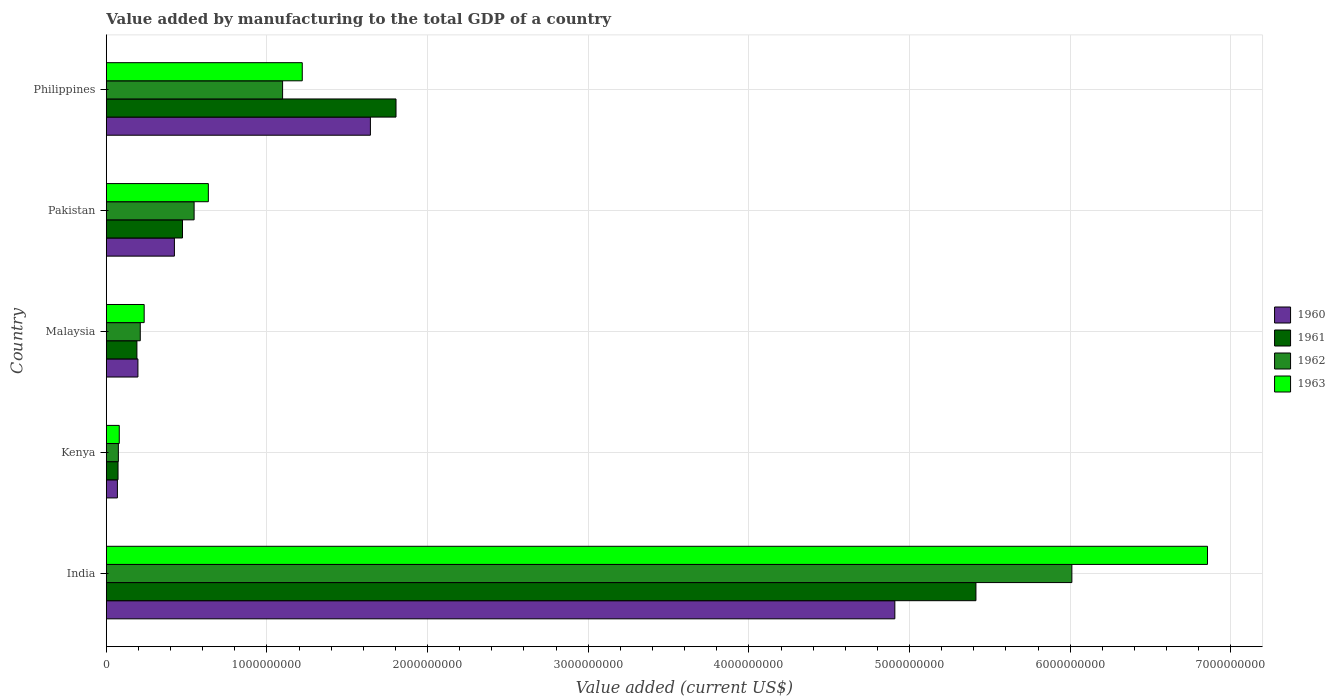How many groups of bars are there?
Offer a very short reply. 5. How many bars are there on the 3rd tick from the bottom?
Make the answer very short. 4. What is the label of the 4th group of bars from the top?
Give a very brief answer. Kenya. What is the value added by manufacturing to the total GDP in 1963 in Pakistan?
Offer a very short reply. 6.35e+08. Across all countries, what is the maximum value added by manufacturing to the total GDP in 1962?
Your response must be concise. 6.01e+09. Across all countries, what is the minimum value added by manufacturing to the total GDP in 1961?
Your response must be concise. 7.28e+07. In which country was the value added by manufacturing to the total GDP in 1960 maximum?
Ensure brevity in your answer.  India. In which country was the value added by manufacturing to the total GDP in 1960 minimum?
Your answer should be compact. Kenya. What is the total value added by manufacturing to the total GDP in 1960 in the graph?
Your response must be concise. 7.24e+09. What is the difference between the value added by manufacturing to the total GDP in 1962 in Kenya and that in Malaysia?
Offer a very short reply. -1.36e+08. What is the difference between the value added by manufacturing to the total GDP in 1960 in India and the value added by manufacturing to the total GDP in 1961 in Malaysia?
Keep it short and to the point. 4.72e+09. What is the average value added by manufacturing to the total GDP in 1961 per country?
Offer a very short reply. 1.59e+09. What is the difference between the value added by manufacturing to the total GDP in 1963 and value added by manufacturing to the total GDP in 1961 in India?
Keep it short and to the point. 1.44e+09. In how many countries, is the value added by manufacturing to the total GDP in 1960 greater than 5400000000 US$?
Provide a succinct answer. 0. What is the ratio of the value added by manufacturing to the total GDP in 1960 in Kenya to that in Pakistan?
Provide a short and direct response. 0.16. Is the value added by manufacturing to the total GDP in 1963 in India less than that in Pakistan?
Ensure brevity in your answer.  No. What is the difference between the highest and the second highest value added by manufacturing to the total GDP in 1960?
Make the answer very short. 3.26e+09. What is the difference between the highest and the lowest value added by manufacturing to the total GDP in 1960?
Your response must be concise. 4.84e+09. In how many countries, is the value added by manufacturing to the total GDP in 1960 greater than the average value added by manufacturing to the total GDP in 1960 taken over all countries?
Give a very brief answer. 2. Is the sum of the value added by manufacturing to the total GDP in 1963 in Kenya and Malaysia greater than the maximum value added by manufacturing to the total GDP in 1960 across all countries?
Your answer should be compact. No. Is it the case that in every country, the sum of the value added by manufacturing to the total GDP in 1963 and value added by manufacturing to the total GDP in 1962 is greater than the sum of value added by manufacturing to the total GDP in 1960 and value added by manufacturing to the total GDP in 1961?
Offer a terse response. No. What does the 4th bar from the top in Malaysia represents?
Provide a short and direct response. 1960. What does the 2nd bar from the bottom in Pakistan represents?
Give a very brief answer. 1961. How many bars are there?
Provide a succinct answer. 20. How many countries are there in the graph?
Provide a succinct answer. 5. What is the difference between two consecutive major ticks on the X-axis?
Offer a very short reply. 1.00e+09. Are the values on the major ticks of X-axis written in scientific E-notation?
Provide a succinct answer. No. Does the graph contain any zero values?
Give a very brief answer. No. How are the legend labels stacked?
Your answer should be very brief. Vertical. What is the title of the graph?
Offer a terse response. Value added by manufacturing to the total GDP of a country. Does "2003" appear as one of the legend labels in the graph?
Your answer should be very brief. No. What is the label or title of the X-axis?
Provide a short and direct response. Value added (current US$). What is the label or title of the Y-axis?
Provide a short and direct response. Country. What is the Value added (current US$) in 1960 in India?
Offer a very short reply. 4.91e+09. What is the Value added (current US$) of 1961 in India?
Your answer should be compact. 5.41e+09. What is the Value added (current US$) of 1962 in India?
Provide a short and direct response. 6.01e+09. What is the Value added (current US$) in 1963 in India?
Your answer should be very brief. 6.85e+09. What is the Value added (current US$) of 1960 in Kenya?
Give a very brief answer. 6.89e+07. What is the Value added (current US$) of 1961 in Kenya?
Make the answer very short. 7.28e+07. What is the Value added (current US$) in 1962 in Kenya?
Your response must be concise. 7.48e+07. What is the Value added (current US$) in 1963 in Kenya?
Your answer should be very brief. 8.05e+07. What is the Value added (current US$) in 1960 in Malaysia?
Provide a succinct answer. 1.97e+08. What is the Value added (current US$) of 1961 in Malaysia?
Keep it short and to the point. 1.90e+08. What is the Value added (current US$) in 1962 in Malaysia?
Give a very brief answer. 2.11e+08. What is the Value added (current US$) of 1963 in Malaysia?
Offer a terse response. 2.36e+08. What is the Value added (current US$) of 1960 in Pakistan?
Make the answer very short. 4.24e+08. What is the Value added (current US$) in 1961 in Pakistan?
Provide a succinct answer. 4.74e+08. What is the Value added (current US$) in 1962 in Pakistan?
Provide a succinct answer. 5.46e+08. What is the Value added (current US$) in 1963 in Pakistan?
Ensure brevity in your answer.  6.35e+08. What is the Value added (current US$) of 1960 in Philippines?
Make the answer very short. 1.64e+09. What is the Value added (current US$) of 1961 in Philippines?
Ensure brevity in your answer.  1.80e+09. What is the Value added (current US$) of 1962 in Philippines?
Ensure brevity in your answer.  1.10e+09. What is the Value added (current US$) of 1963 in Philippines?
Your answer should be very brief. 1.22e+09. Across all countries, what is the maximum Value added (current US$) of 1960?
Your answer should be compact. 4.91e+09. Across all countries, what is the maximum Value added (current US$) of 1961?
Keep it short and to the point. 5.41e+09. Across all countries, what is the maximum Value added (current US$) of 1962?
Give a very brief answer. 6.01e+09. Across all countries, what is the maximum Value added (current US$) of 1963?
Ensure brevity in your answer.  6.85e+09. Across all countries, what is the minimum Value added (current US$) in 1960?
Your response must be concise. 6.89e+07. Across all countries, what is the minimum Value added (current US$) of 1961?
Provide a succinct answer. 7.28e+07. Across all countries, what is the minimum Value added (current US$) in 1962?
Give a very brief answer. 7.48e+07. Across all countries, what is the minimum Value added (current US$) of 1963?
Your answer should be very brief. 8.05e+07. What is the total Value added (current US$) in 1960 in the graph?
Your response must be concise. 7.24e+09. What is the total Value added (current US$) of 1961 in the graph?
Offer a terse response. 7.95e+09. What is the total Value added (current US$) of 1962 in the graph?
Provide a succinct answer. 7.94e+09. What is the total Value added (current US$) in 1963 in the graph?
Keep it short and to the point. 9.03e+09. What is the difference between the Value added (current US$) of 1960 in India and that in Kenya?
Your response must be concise. 4.84e+09. What is the difference between the Value added (current US$) of 1961 in India and that in Kenya?
Keep it short and to the point. 5.34e+09. What is the difference between the Value added (current US$) in 1962 in India and that in Kenya?
Provide a succinct answer. 5.94e+09. What is the difference between the Value added (current US$) in 1963 in India and that in Kenya?
Your answer should be compact. 6.77e+09. What is the difference between the Value added (current US$) in 1960 in India and that in Malaysia?
Provide a succinct answer. 4.71e+09. What is the difference between the Value added (current US$) in 1961 in India and that in Malaysia?
Provide a succinct answer. 5.22e+09. What is the difference between the Value added (current US$) in 1962 in India and that in Malaysia?
Provide a short and direct response. 5.80e+09. What is the difference between the Value added (current US$) in 1963 in India and that in Malaysia?
Provide a short and direct response. 6.62e+09. What is the difference between the Value added (current US$) of 1960 in India and that in Pakistan?
Your answer should be very brief. 4.48e+09. What is the difference between the Value added (current US$) in 1961 in India and that in Pakistan?
Offer a very short reply. 4.94e+09. What is the difference between the Value added (current US$) in 1962 in India and that in Pakistan?
Ensure brevity in your answer.  5.46e+09. What is the difference between the Value added (current US$) of 1963 in India and that in Pakistan?
Keep it short and to the point. 6.22e+09. What is the difference between the Value added (current US$) in 1960 in India and that in Philippines?
Give a very brief answer. 3.26e+09. What is the difference between the Value added (current US$) of 1961 in India and that in Philippines?
Provide a short and direct response. 3.61e+09. What is the difference between the Value added (current US$) of 1962 in India and that in Philippines?
Keep it short and to the point. 4.91e+09. What is the difference between the Value added (current US$) in 1963 in India and that in Philippines?
Give a very brief answer. 5.64e+09. What is the difference between the Value added (current US$) in 1960 in Kenya and that in Malaysia?
Your response must be concise. -1.28e+08. What is the difference between the Value added (current US$) of 1961 in Kenya and that in Malaysia?
Ensure brevity in your answer.  -1.18e+08. What is the difference between the Value added (current US$) in 1962 in Kenya and that in Malaysia?
Ensure brevity in your answer.  -1.36e+08. What is the difference between the Value added (current US$) of 1963 in Kenya and that in Malaysia?
Provide a succinct answer. -1.55e+08. What is the difference between the Value added (current US$) in 1960 in Kenya and that in Pakistan?
Your answer should be compact. -3.55e+08. What is the difference between the Value added (current US$) of 1961 in Kenya and that in Pakistan?
Your answer should be very brief. -4.01e+08. What is the difference between the Value added (current US$) in 1962 in Kenya and that in Pakistan?
Provide a succinct answer. -4.72e+08. What is the difference between the Value added (current US$) of 1963 in Kenya and that in Pakistan?
Your answer should be compact. -5.54e+08. What is the difference between the Value added (current US$) of 1960 in Kenya and that in Philippines?
Make the answer very short. -1.57e+09. What is the difference between the Value added (current US$) in 1961 in Kenya and that in Philippines?
Your answer should be compact. -1.73e+09. What is the difference between the Value added (current US$) in 1962 in Kenya and that in Philippines?
Your response must be concise. -1.02e+09. What is the difference between the Value added (current US$) of 1963 in Kenya and that in Philippines?
Provide a succinct answer. -1.14e+09. What is the difference between the Value added (current US$) in 1960 in Malaysia and that in Pakistan?
Your answer should be compact. -2.27e+08. What is the difference between the Value added (current US$) of 1961 in Malaysia and that in Pakistan?
Keep it short and to the point. -2.84e+08. What is the difference between the Value added (current US$) in 1962 in Malaysia and that in Pakistan?
Offer a terse response. -3.35e+08. What is the difference between the Value added (current US$) in 1963 in Malaysia and that in Pakistan?
Your answer should be compact. -3.99e+08. What is the difference between the Value added (current US$) in 1960 in Malaysia and that in Philippines?
Your answer should be very brief. -1.45e+09. What is the difference between the Value added (current US$) of 1961 in Malaysia and that in Philippines?
Offer a terse response. -1.61e+09. What is the difference between the Value added (current US$) of 1962 in Malaysia and that in Philippines?
Give a very brief answer. -8.86e+08. What is the difference between the Value added (current US$) in 1963 in Malaysia and that in Philippines?
Offer a terse response. -9.84e+08. What is the difference between the Value added (current US$) of 1960 in Pakistan and that in Philippines?
Offer a very short reply. -1.22e+09. What is the difference between the Value added (current US$) of 1961 in Pakistan and that in Philippines?
Offer a terse response. -1.33e+09. What is the difference between the Value added (current US$) of 1962 in Pakistan and that in Philippines?
Provide a succinct answer. -5.51e+08. What is the difference between the Value added (current US$) of 1963 in Pakistan and that in Philippines?
Make the answer very short. -5.85e+08. What is the difference between the Value added (current US$) in 1960 in India and the Value added (current US$) in 1961 in Kenya?
Your answer should be very brief. 4.84e+09. What is the difference between the Value added (current US$) in 1960 in India and the Value added (current US$) in 1962 in Kenya?
Provide a short and direct response. 4.83e+09. What is the difference between the Value added (current US$) in 1960 in India and the Value added (current US$) in 1963 in Kenya?
Offer a terse response. 4.83e+09. What is the difference between the Value added (current US$) of 1961 in India and the Value added (current US$) of 1962 in Kenya?
Your response must be concise. 5.34e+09. What is the difference between the Value added (current US$) of 1961 in India and the Value added (current US$) of 1963 in Kenya?
Provide a short and direct response. 5.33e+09. What is the difference between the Value added (current US$) in 1962 in India and the Value added (current US$) in 1963 in Kenya?
Your answer should be compact. 5.93e+09. What is the difference between the Value added (current US$) in 1960 in India and the Value added (current US$) in 1961 in Malaysia?
Ensure brevity in your answer.  4.72e+09. What is the difference between the Value added (current US$) in 1960 in India and the Value added (current US$) in 1962 in Malaysia?
Make the answer very short. 4.70e+09. What is the difference between the Value added (current US$) in 1960 in India and the Value added (current US$) in 1963 in Malaysia?
Provide a succinct answer. 4.67e+09. What is the difference between the Value added (current US$) in 1961 in India and the Value added (current US$) in 1962 in Malaysia?
Provide a short and direct response. 5.20e+09. What is the difference between the Value added (current US$) of 1961 in India and the Value added (current US$) of 1963 in Malaysia?
Offer a terse response. 5.18e+09. What is the difference between the Value added (current US$) in 1962 in India and the Value added (current US$) in 1963 in Malaysia?
Offer a terse response. 5.78e+09. What is the difference between the Value added (current US$) of 1960 in India and the Value added (current US$) of 1961 in Pakistan?
Make the answer very short. 4.43e+09. What is the difference between the Value added (current US$) in 1960 in India and the Value added (current US$) in 1962 in Pakistan?
Your answer should be compact. 4.36e+09. What is the difference between the Value added (current US$) in 1960 in India and the Value added (current US$) in 1963 in Pakistan?
Provide a short and direct response. 4.27e+09. What is the difference between the Value added (current US$) in 1961 in India and the Value added (current US$) in 1962 in Pakistan?
Offer a very short reply. 4.87e+09. What is the difference between the Value added (current US$) of 1961 in India and the Value added (current US$) of 1963 in Pakistan?
Your answer should be very brief. 4.78e+09. What is the difference between the Value added (current US$) of 1962 in India and the Value added (current US$) of 1963 in Pakistan?
Your answer should be compact. 5.38e+09. What is the difference between the Value added (current US$) of 1960 in India and the Value added (current US$) of 1961 in Philippines?
Provide a short and direct response. 3.11e+09. What is the difference between the Value added (current US$) of 1960 in India and the Value added (current US$) of 1962 in Philippines?
Give a very brief answer. 3.81e+09. What is the difference between the Value added (current US$) of 1960 in India and the Value added (current US$) of 1963 in Philippines?
Provide a succinct answer. 3.69e+09. What is the difference between the Value added (current US$) in 1961 in India and the Value added (current US$) in 1962 in Philippines?
Offer a terse response. 4.32e+09. What is the difference between the Value added (current US$) in 1961 in India and the Value added (current US$) in 1963 in Philippines?
Provide a succinct answer. 4.19e+09. What is the difference between the Value added (current US$) in 1962 in India and the Value added (current US$) in 1963 in Philippines?
Provide a short and direct response. 4.79e+09. What is the difference between the Value added (current US$) in 1960 in Kenya and the Value added (current US$) in 1961 in Malaysia?
Your response must be concise. -1.21e+08. What is the difference between the Value added (current US$) of 1960 in Kenya and the Value added (current US$) of 1962 in Malaysia?
Make the answer very short. -1.42e+08. What is the difference between the Value added (current US$) in 1960 in Kenya and the Value added (current US$) in 1963 in Malaysia?
Ensure brevity in your answer.  -1.67e+08. What is the difference between the Value added (current US$) of 1961 in Kenya and the Value added (current US$) of 1962 in Malaysia?
Make the answer very short. -1.38e+08. What is the difference between the Value added (current US$) of 1961 in Kenya and the Value added (current US$) of 1963 in Malaysia?
Provide a succinct answer. -1.63e+08. What is the difference between the Value added (current US$) in 1962 in Kenya and the Value added (current US$) in 1963 in Malaysia?
Your answer should be compact. -1.61e+08. What is the difference between the Value added (current US$) of 1960 in Kenya and the Value added (current US$) of 1961 in Pakistan?
Provide a succinct answer. -4.05e+08. What is the difference between the Value added (current US$) of 1960 in Kenya and the Value added (current US$) of 1962 in Pakistan?
Your answer should be very brief. -4.78e+08. What is the difference between the Value added (current US$) of 1960 in Kenya and the Value added (current US$) of 1963 in Pakistan?
Provide a short and direct response. -5.66e+08. What is the difference between the Value added (current US$) in 1961 in Kenya and the Value added (current US$) in 1962 in Pakistan?
Provide a short and direct response. -4.74e+08. What is the difference between the Value added (current US$) of 1961 in Kenya and the Value added (current US$) of 1963 in Pakistan?
Ensure brevity in your answer.  -5.62e+08. What is the difference between the Value added (current US$) of 1962 in Kenya and the Value added (current US$) of 1963 in Pakistan?
Provide a succinct answer. -5.60e+08. What is the difference between the Value added (current US$) of 1960 in Kenya and the Value added (current US$) of 1961 in Philippines?
Provide a succinct answer. -1.73e+09. What is the difference between the Value added (current US$) of 1960 in Kenya and the Value added (current US$) of 1962 in Philippines?
Make the answer very short. -1.03e+09. What is the difference between the Value added (current US$) of 1960 in Kenya and the Value added (current US$) of 1963 in Philippines?
Offer a very short reply. -1.15e+09. What is the difference between the Value added (current US$) of 1961 in Kenya and the Value added (current US$) of 1962 in Philippines?
Your answer should be very brief. -1.02e+09. What is the difference between the Value added (current US$) in 1961 in Kenya and the Value added (current US$) in 1963 in Philippines?
Provide a succinct answer. -1.15e+09. What is the difference between the Value added (current US$) in 1962 in Kenya and the Value added (current US$) in 1963 in Philippines?
Your response must be concise. -1.14e+09. What is the difference between the Value added (current US$) in 1960 in Malaysia and the Value added (current US$) in 1961 in Pakistan?
Offer a very short reply. -2.78e+08. What is the difference between the Value added (current US$) in 1960 in Malaysia and the Value added (current US$) in 1962 in Pakistan?
Make the answer very short. -3.50e+08. What is the difference between the Value added (current US$) in 1960 in Malaysia and the Value added (current US$) in 1963 in Pakistan?
Offer a very short reply. -4.38e+08. What is the difference between the Value added (current US$) of 1961 in Malaysia and the Value added (current US$) of 1962 in Pakistan?
Provide a short and direct response. -3.56e+08. What is the difference between the Value added (current US$) of 1961 in Malaysia and the Value added (current US$) of 1963 in Pakistan?
Provide a succinct answer. -4.45e+08. What is the difference between the Value added (current US$) of 1962 in Malaysia and the Value added (current US$) of 1963 in Pakistan?
Keep it short and to the point. -4.24e+08. What is the difference between the Value added (current US$) of 1960 in Malaysia and the Value added (current US$) of 1961 in Philippines?
Give a very brief answer. -1.61e+09. What is the difference between the Value added (current US$) of 1960 in Malaysia and the Value added (current US$) of 1962 in Philippines?
Keep it short and to the point. -9.01e+08. What is the difference between the Value added (current US$) of 1960 in Malaysia and the Value added (current US$) of 1963 in Philippines?
Give a very brief answer. -1.02e+09. What is the difference between the Value added (current US$) in 1961 in Malaysia and the Value added (current US$) in 1962 in Philippines?
Offer a terse response. -9.07e+08. What is the difference between the Value added (current US$) of 1961 in Malaysia and the Value added (current US$) of 1963 in Philippines?
Offer a very short reply. -1.03e+09. What is the difference between the Value added (current US$) in 1962 in Malaysia and the Value added (current US$) in 1963 in Philippines?
Keep it short and to the point. -1.01e+09. What is the difference between the Value added (current US$) of 1960 in Pakistan and the Value added (current US$) of 1961 in Philippines?
Offer a very short reply. -1.38e+09. What is the difference between the Value added (current US$) of 1960 in Pakistan and the Value added (current US$) of 1962 in Philippines?
Your response must be concise. -6.74e+08. What is the difference between the Value added (current US$) of 1960 in Pakistan and the Value added (current US$) of 1963 in Philippines?
Offer a very short reply. -7.96e+08. What is the difference between the Value added (current US$) of 1961 in Pakistan and the Value added (current US$) of 1962 in Philippines?
Give a very brief answer. -6.23e+08. What is the difference between the Value added (current US$) of 1961 in Pakistan and the Value added (current US$) of 1963 in Philippines?
Offer a terse response. -7.46e+08. What is the difference between the Value added (current US$) of 1962 in Pakistan and the Value added (current US$) of 1963 in Philippines?
Provide a succinct answer. -6.73e+08. What is the average Value added (current US$) of 1960 per country?
Your answer should be compact. 1.45e+09. What is the average Value added (current US$) in 1961 per country?
Offer a terse response. 1.59e+09. What is the average Value added (current US$) of 1962 per country?
Ensure brevity in your answer.  1.59e+09. What is the average Value added (current US$) in 1963 per country?
Make the answer very short. 1.81e+09. What is the difference between the Value added (current US$) in 1960 and Value added (current US$) in 1961 in India?
Offer a terse response. -5.05e+08. What is the difference between the Value added (current US$) of 1960 and Value added (current US$) of 1962 in India?
Your response must be concise. -1.10e+09. What is the difference between the Value added (current US$) of 1960 and Value added (current US$) of 1963 in India?
Your answer should be very brief. -1.95e+09. What is the difference between the Value added (current US$) of 1961 and Value added (current US$) of 1962 in India?
Give a very brief answer. -5.97e+08. What is the difference between the Value added (current US$) of 1961 and Value added (current US$) of 1963 in India?
Your answer should be compact. -1.44e+09. What is the difference between the Value added (current US$) of 1962 and Value added (current US$) of 1963 in India?
Give a very brief answer. -8.44e+08. What is the difference between the Value added (current US$) in 1960 and Value added (current US$) in 1961 in Kenya?
Give a very brief answer. -3.93e+06. What is the difference between the Value added (current US$) in 1960 and Value added (current US$) in 1962 in Kenya?
Provide a short and direct response. -5.94e+06. What is the difference between the Value added (current US$) of 1960 and Value added (current US$) of 1963 in Kenya?
Offer a terse response. -1.16e+07. What is the difference between the Value added (current US$) in 1961 and Value added (current US$) in 1962 in Kenya?
Provide a succinct answer. -2.00e+06. What is the difference between the Value added (current US$) in 1961 and Value added (current US$) in 1963 in Kenya?
Offer a terse response. -7.70e+06. What is the difference between the Value added (current US$) of 1962 and Value added (current US$) of 1963 in Kenya?
Your answer should be very brief. -5.70e+06. What is the difference between the Value added (current US$) in 1960 and Value added (current US$) in 1961 in Malaysia?
Your answer should be compact. 6.25e+06. What is the difference between the Value added (current US$) in 1960 and Value added (current US$) in 1962 in Malaysia?
Offer a terse response. -1.46e+07. What is the difference between the Value added (current US$) of 1960 and Value added (current US$) of 1963 in Malaysia?
Offer a very short reply. -3.89e+07. What is the difference between the Value added (current US$) in 1961 and Value added (current US$) in 1962 in Malaysia?
Offer a terse response. -2.08e+07. What is the difference between the Value added (current US$) in 1961 and Value added (current US$) in 1963 in Malaysia?
Ensure brevity in your answer.  -4.52e+07. What is the difference between the Value added (current US$) of 1962 and Value added (current US$) of 1963 in Malaysia?
Ensure brevity in your answer.  -2.43e+07. What is the difference between the Value added (current US$) in 1960 and Value added (current US$) in 1961 in Pakistan?
Your answer should be very brief. -5.04e+07. What is the difference between the Value added (current US$) in 1960 and Value added (current US$) in 1962 in Pakistan?
Your response must be concise. -1.23e+08. What is the difference between the Value added (current US$) of 1960 and Value added (current US$) of 1963 in Pakistan?
Your response must be concise. -2.11e+08. What is the difference between the Value added (current US$) in 1961 and Value added (current US$) in 1962 in Pakistan?
Your response must be concise. -7.22e+07. What is the difference between the Value added (current US$) in 1961 and Value added (current US$) in 1963 in Pakistan?
Provide a short and direct response. -1.61e+08. What is the difference between the Value added (current US$) of 1962 and Value added (current US$) of 1963 in Pakistan?
Provide a short and direct response. -8.86e+07. What is the difference between the Value added (current US$) in 1960 and Value added (current US$) in 1961 in Philippines?
Your response must be concise. -1.59e+08. What is the difference between the Value added (current US$) in 1960 and Value added (current US$) in 1962 in Philippines?
Make the answer very short. 5.47e+08. What is the difference between the Value added (current US$) of 1960 and Value added (current US$) of 1963 in Philippines?
Give a very brief answer. 4.24e+08. What is the difference between the Value added (current US$) of 1961 and Value added (current US$) of 1962 in Philippines?
Provide a succinct answer. 7.06e+08. What is the difference between the Value added (current US$) in 1961 and Value added (current US$) in 1963 in Philippines?
Ensure brevity in your answer.  5.84e+08. What is the difference between the Value added (current US$) of 1962 and Value added (current US$) of 1963 in Philippines?
Make the answer very short. -1.22e+08. What is the ratio of the Value added (current US$) of 1960 in India to that in Kenya?
Make the answer very short. 71.24. What is the ratio of the Value added (current US$) of 1961 in India to that in Kenya?
Your response must be concise. 74.32. What is the ratio of the Value added (current US$) of 1962 in India to that in Kenya?
Your answer should be compact. 80.31. What is the ratio of the Value added (current US$) of 1963 in India to that in Kenya?
Make the answer very short. 85.11. What is the ratio of the Value added (current US$) of 1960 in India to that in Malaysia?
Provide a succinct answer. 24.96. What is the ratio of the Value added (current US$) in 1961 in India to that in Malaysia?
Your response must be concise. 28.44. What is the ratio of the Value added (current US$) of 1962 in India to that in Malaysia?
Give a very brief answer. 28.46. What is the ratio of the Value added (current US$) of 1963 in India to that in Malaysia?
Your answer should be compact. 29.1. What is the ratio of the Value added (current US$) in 1960 in India to that in Pakistan?
Ensure brevity in your answer.  11.58. What is the ratio of the Value added (current US$) in 1961 in India to that in Pakistan?
Provide a succinct answer. 11.42. What is the ratio of the Value added (current US$) of 1962 in India to that in Pakistan?
Offer a very short reply. 11. What is the ratio of the Value added (current US$) in 1963 in India to that in Pakistan?
Ensure brevity in your answer.  10.79. What is the ratio of the Value added (current US$) in 1960 in India to that in Philippines?
Give a very brief answer. 2.99. What is the ratio of the Value added (current US$) in 1961 in India to that in Philippines?
Provide a short and direct response. 3. What is the ratio of the Value added (current US$) of 1962 in India to that in Philippines?
Provide a short and direct response. 5.48. What is the ratio of the Value added (current US$) in 1963 in India to that in Philippines?
Provide a short and direct response. 5.62. What is the ratio of the Value added (current US$) in 1960 in Kenya to that in Malaysia?
Your response must be concise. 0.35. What is the ratio of the Value added (current US$) in 1961 in Kenya to that in Malaysia?
Keep it short and to the point. 0.38. What is the ratio of the Value added (current US$) in 1962 in Kenya to that in Malaysia?
Provide a succinct answer. 0.35. What is the ratio of the Value added (current US$) of 1963 in Kenya to that in Malaysia?
Keep it short and to the point. 0.34. What is the ratio of the Value added (current US$) of 1960 in Kenya to that in Pakistan?
Your response must be concise. 0.16. What is the ratio of the Value added (current US$) of 1961 in Kenya to that in Pakistan?
Offer a very short reply. 0.15. What is the ratio of the Value added (current US$) of 1962 in Kenya to that in Pakistan?
Offer a terse response. 0.14. What is the ratio of the Value added (current US$) of 1963 in Kenya to that in Pakistan?
Your response must be concise. 0.13. What is the ratio of the Value added (current US$) of 1960 in Kenya to that in Philippines?
Provide a succinct answer. 0.04. What is the ratio of the Value added (current US$) in 1961 in Kenya to that in Philippines?
Your answer should be very brief. 0.04. What is the ratio of the Value added (current US$) of 1962 in Kenya to that in Philippines?
Your answer should be very brief. 0.07. What is the ratio of the Value added (current US$) of 1963 in Kenya to that in Philippines?
Keep it short and to the point. 0.07. What is the ratio of the Value added (current US$) in 1960 in Malaysia to that in Pakistan?
Offer a terse response. 0.46. What is the ratio of the Value added (current US$) of 1961 in Malaysia to that in Pakistan?
Provide a short and direct response. 0.4. What is the ratio of the Value added (current US$) of 1962 in Malaysia to that in Pakistan?
Provide a short and direct response. 0.39. What is the ratio of the Value added (current US$) of 1963 in Malaysia to that in Pakistan?
Your answer should be compact. 0.37. What is the ratio of the Value added (current US$) in 1960 in Malaysia to that in Philippines?
Ensure brevity in your answer.  0.12. What is the ratio of the Value added (current US$) of 1961 in Malaysia to that in Philippines?
Your response must be concise. 0.11. What is the ratio of the Value added (current US$) of 1962 in Malaysia to that in Philippines?
Ensure brevity in your answer.  0.19. What is the ratio of the Value added (current US$) of 1963 in Malaysia to that in Philippines?
Give a very brief answer. 0.19. What is the ratio of the Value added (current US$) in 1960 in Pakistan to that in Philippines?
Make the answer very short. 0.26. What is the ratio of the Value added (current US$) in 1961 in Pakistan to that in Philippines?
Keep it short and to the point. 0.26. What is the ratio of the Value added (current US$) in 1962 in Pakistan to that in Philippines?
Ensure brevity in your answer.  0.5. What is the ratio of the Value added (current US$) of 1963 in Pakistan to that in Philippines?
Your response must be concise. 0.52. What is the difference between the highest and the second highest Value added (current US$) of 1960?
Your answer should be compact. 3.26e+09. What is the difference between the highest and the second highest Value added (current US$) in 1961?
Offer a terse response. 3.61e+09. What is the difference between the highest and the second highest Value added (current US$) in 1962?
Offer a terse response. 4.91e+09. What is the difference between the highest and the second highest Value added (current US$) of 1963?
Ensure brevity in your answer.  5.64e+09. What is the difference between the highest and the lowest Value added (current US$) of 1960?
Provide a short and direct response. 4.84e+09. What is the difference between the highest and the lowest Value added (current US$) of 1961?
Offer a very short reply. 5.34e+09. What is the difference between the highest and the lowest Value added (current US$) of 1962?
Make the answer very short. 5.94e+09. What is the difference between the highest and the lowest Value added (current US$) in 1963?
Your response must be concise. 6.77e+09. 